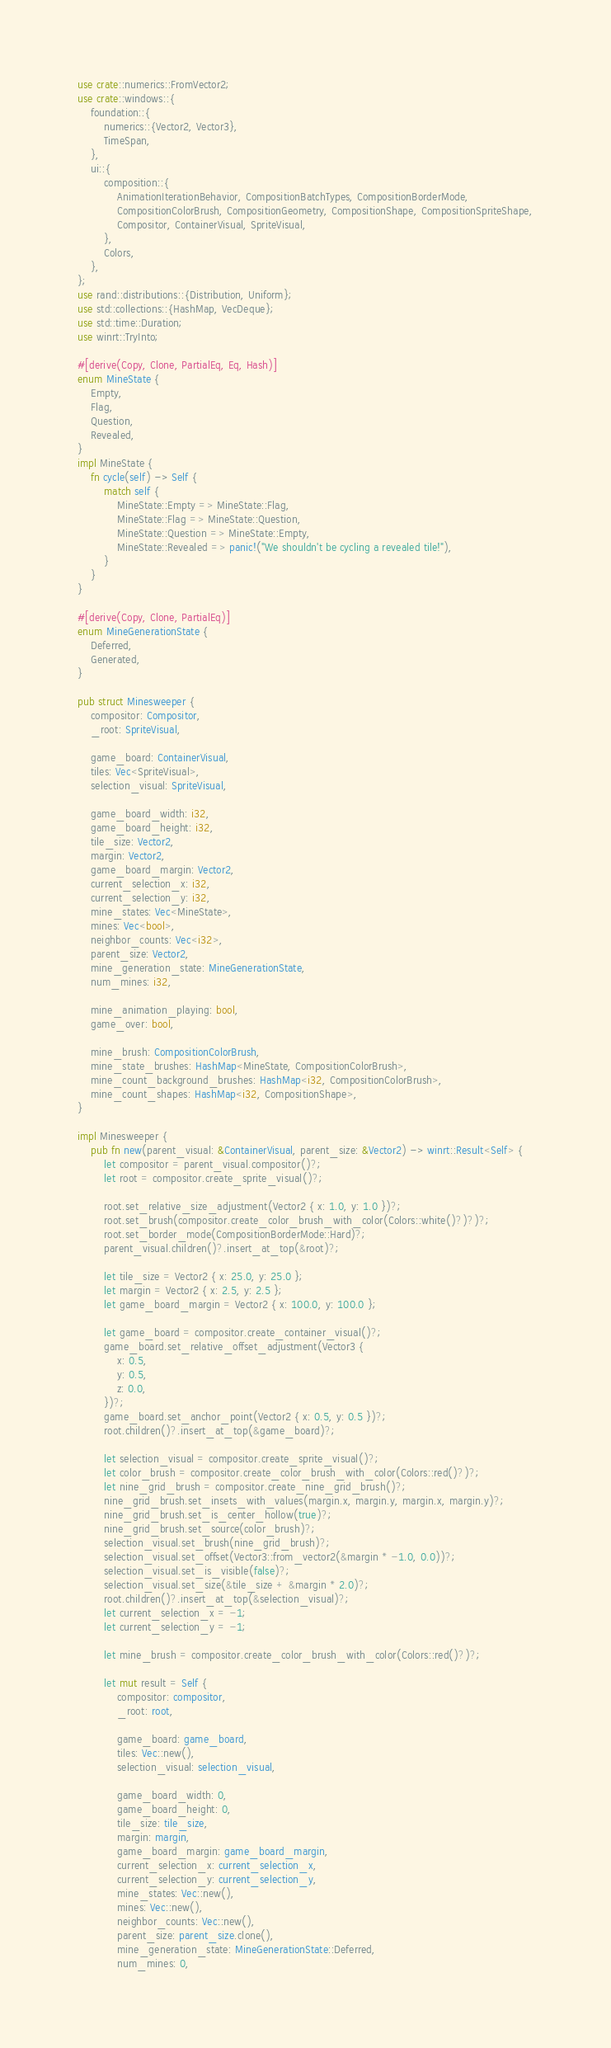<code> <loc_0><loc_0><loc_500><loc_500><_Rust_>use crate::numerics::FromVector2;
use crate::windows::{
    foundation::{
        numerics::{Vector2, Vector3},
        TimeSpan,
    },
    ui::{
        composition::{
            AnimationIterationBehavior, CompositionBatchTypes, CompositionBorderMode,
            CompositionColorBrush, CompositionGeometry, CompositionShape, CompositionSpriteShape,
            Compositor, ContainerVisual, SpriteVisual,
        },
        Colors,
    },
};
use rand::distributions::{Distribution, Uniform};
use std::collections::{HashMap, VecDeque};
use std::time::Duration;
use winrt::TryInto;

#[derive(Copy, Clone, PartialEq, Eq, Hash)]
enum MineState {
    Empty,
    Flag,
    Question,
    Revealed,
}
impl MineState {
    fn cycle(self) -> Self {
        match self {
            MineState::Empty => MineState::Flag,
            MineState::Flag => MineState::Question,
            MineState::Question => MineState::Empty,
            MineState::Revealed => panic!("We shouldn't be cycling a revealed tile!"),
        }
    }
}

#[derive(Copy, Clone, PartialEq)]
enum MineGenerationState {
    Deferred,
    Generated,
}

pub struct Minesweeper {
    compositor: Compositor,
    _root: SpriteVisual,

    game_board: ContainerVisual,
    tiles: Vec<SpriteVisual>,
    selection_visual: SpriteVisual,

    game_board_width: i32,
    game_board_height: i32,
    tile_size: Vector2,
    margin: Vector2,
    game_board_margin: Vector2,
    current_selection_x: i32,
    current_selection_y: i32,
    mine_states: Vec<MineState>,
    mines: Vec<bool>,
    neighbor_counts: Vec<i32>,
    parent_size: Vector2,
    mine_generation_state: MineGenerationState,
    num_mines: i32,

    mine_animation_playing: bool,
    game_over: bool,

    mine_brush: CompositionColorBrush,
    mine_state_brushes: HashMap<MineState, CompositionColorBrush>,
    mine_count_background_brushes: HashMap<i32, CompositionColorBrush>,
    mine_count_shapes: HashMap<i32, CompositionShape>,
}

impl Minesweeper {
    pub fn new(parent_visual: &ContainerVisual, parent_size: &Vector2) -> winrt::Result<Self> {
        let compositor = parent_visual.compositor()?;
        let root = compositor.create_sprite_visual()?;

        root.set_relative_size_adjustment(Vector2 { x: 1.0, y: 1.0 })?;
        root.set_brush(compositor.create_color_brush_with_color(Colors::white()?)?)?;
        root.set_border_mode(CompositionBorderMode::Hard)?;
        parent_visual.children()?.insert_at_top(&root)?;

        let tile_size = Vector2 { x: 25.0, y: 25.0 };
        let margin = Vector2 { x: 2.5, y: 2.5 };
        let game_board_margin = Vector2 { x: 100.0, y: 100.0 };

        let game_board = compositor.create_container_visual()?;
        game_board.set_relative_offset_adjustment(Vector3 {
            x: 0.5,
            y: 0.5,
            z: 0.0,
        })?;
        game_board.set_anchor_point(Vector2 { x: 0.5, y: 0.5 })?;
        root.children()?.insert_at_top(&game_board)?;

        let selection_visual = compositor.create_sprite_visual()?;
        let color_brush = compositor.create_color_brush_with_color(Colors::red()?)?;
        let nine_grid_brush = compositor.create_nine_grid_brush()?;
        nine_grid_brush.set_insets_with_values(margin.x, margin.y, margin.x, margin.y)?;
        nine_grid_brush.set_is_center_hollow(true)?;
        nine_grid_brush.set_source(color_brush)?;
        selection_visual.set_brush(nine_grid_brush)?;
        selection_visual.set_offset(Vector3::from_vector2(&margin * -1.0, 0.0))?;
        selection_visual.set_is_visible(false)?;
        selection_visual.set_size(&tile_size + &margin * 2.0)?;
        root.children()?.insert_at_top(&selection_visual)?;
        let current_selection_x = -1;
        let current_selection_y = -1;

        let mine_brush = compositor.create_color_brush_with_color(Colors::red()?)?;

        let mut result = Self {
            compositor: compositor,
            _root: root,

            game_board: game_board,
            tiles: Vec::new(),
            selection_visual: selection_visual,

            game_board_width: 0,
            game_board_height: 0,
            tile_size: tile_size,
            margin: margin,
            game_board_margin: game_board_margin,
            current_selection_x: current_selection_x,
            current_selection_y: current_selection_y,
            mine_states: Vec::new(),
            mines: Vec::new(),
            neighbor_counts: Vec::new(),
            parent_size: parent_size.clone(),
            mine_generation_state: MineGenerationState::Deferred,
            num_mines: 0,
</code> 